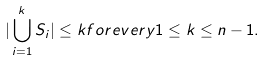Convert formula to latex. <formula><loc_0><loc_0><loc_500><loc_500>| \bigcup _ { i = 1 } ^ { k } S _ { i } | \leq k f o r e v e r y 1 \leq k \leq n - 1 .</formula> 